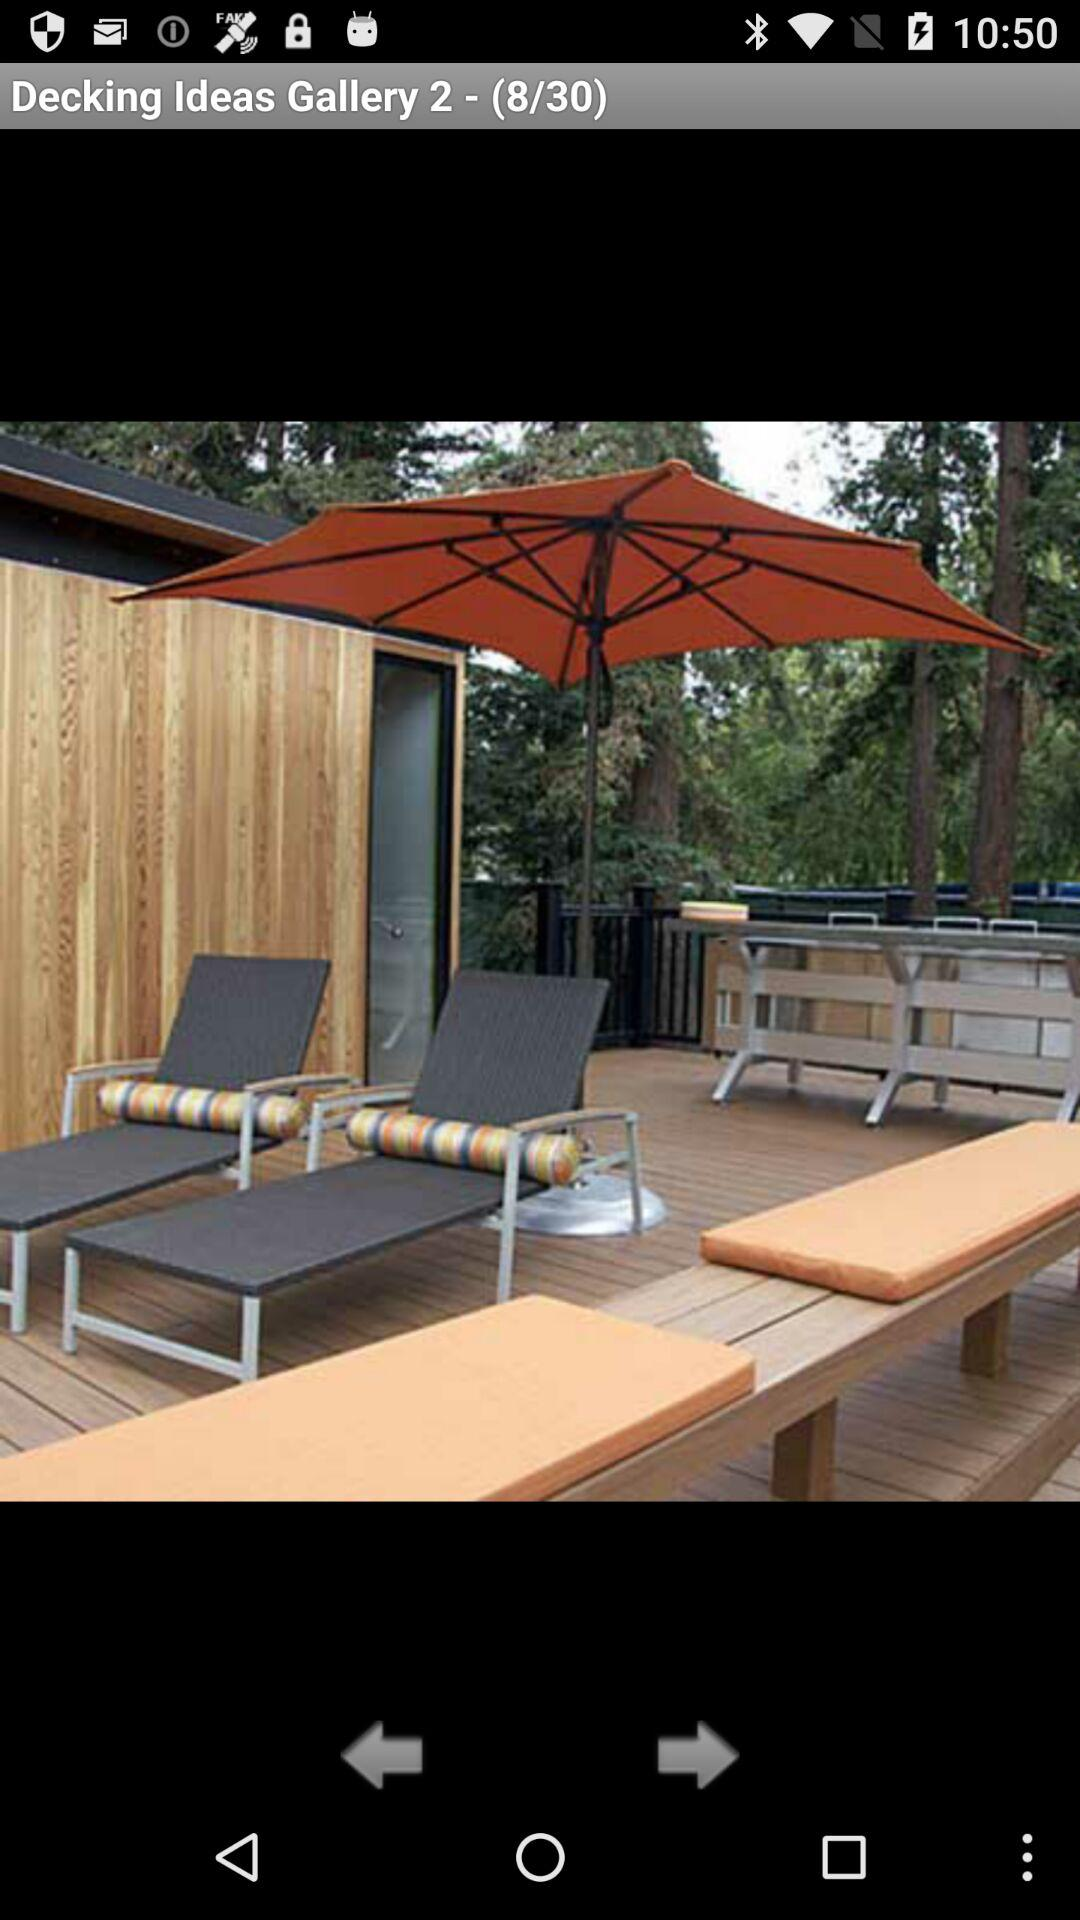At which image am I? You are at image 8. 